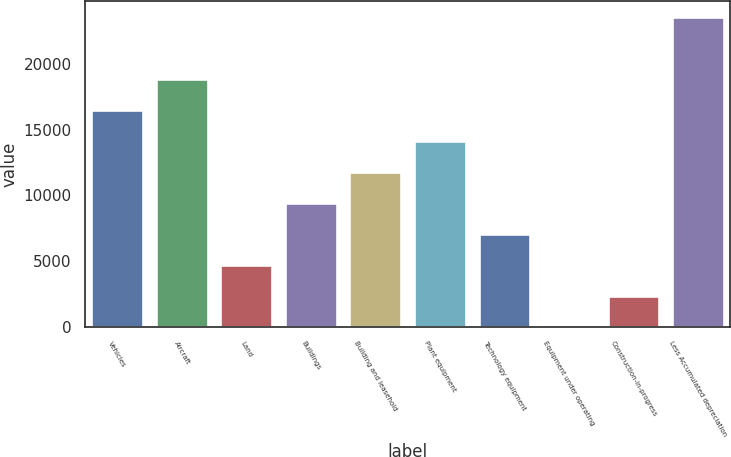Convert chart to OTSL. <chart><loc_0><loc_0><loc_500><loc_500><bar_chart><fcel>Vehicles<fcel>Aircraft<fcel>Land<fcel>Buildings<fcel>Building and leasehold<fcel>Plant equipment<fcel>Technology equipment<fcel>Equipment under operating<fcel>Construction-in-progress<fcel>Less Accumulated depreciation<nl><fcel>16505.2<fcel>18858.8<fcel>4737.2<fcel>9444.4<fcel>11798<fcel>14151.6<fcel>7090.8<fcel>30<fcel>2383.6<fcel>23566<nl></chart> 